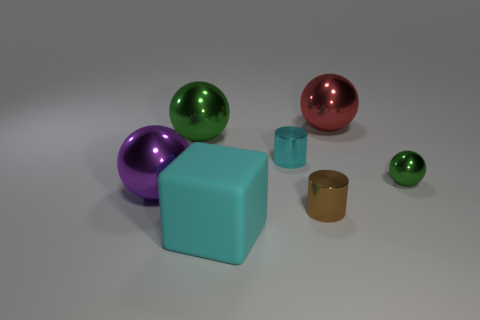Subtract all purple spheres. Subtract all gray blocks. How many spheres are left? 3 Add 1 large red balls. How many objects exist? 8 Subtract all cylinders. How many objects are left? 5 Add 3 purple things. How many purple things are left? 4 Add 6 big balls. How many big balls exist? 9 Subtract 0 cyan balls. How many objects are left? 7 Subtract all large green objects. Subtract all tiny purple shiny spheres. How many objects are left? 6 